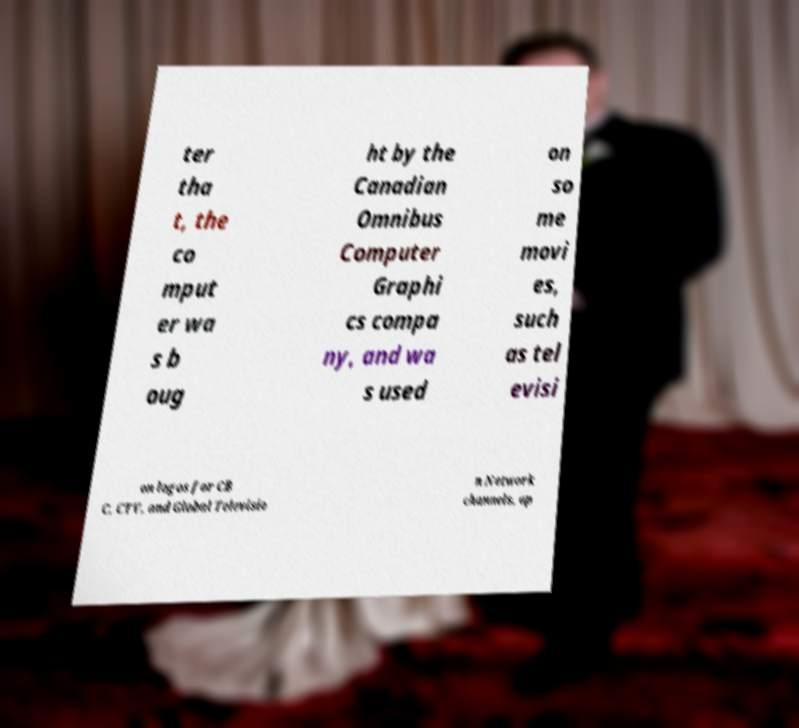Can you accurately transcribe the text from the provided image for me? ter tha t, the co mput er wa s b oug ht by the Canadian Omnibus Computer Graphi cs compa ny, and wa s used on so me movi es, such as tel evisi on logos for CB C, CTV, and Global Televisio n Network channels, op 